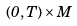<formula> <loc_0><loc_0><loc_500><loc_500>( 0 , T ) \times M</formula> 